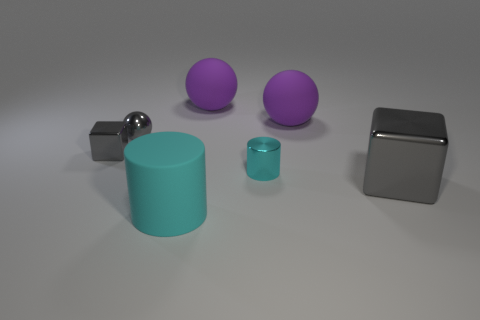Subtract all cyan cylinders. How many were subtracted if there are1cyan cylinders left? 1 Add 1 small cyan things. How many objects exist? 8 Subtract all balls. How many objects are left? 4 Subtract all large gray metallic blocks. Subtract all small cylinders. How many objects are left? 5 Add 7 small metal things. How many small metal things are left? 10 Add 5 big rubber cylinders. How many big rubber cylinders exist? 6 Subtract 0 yellow blocks. How many objects are left? 7 